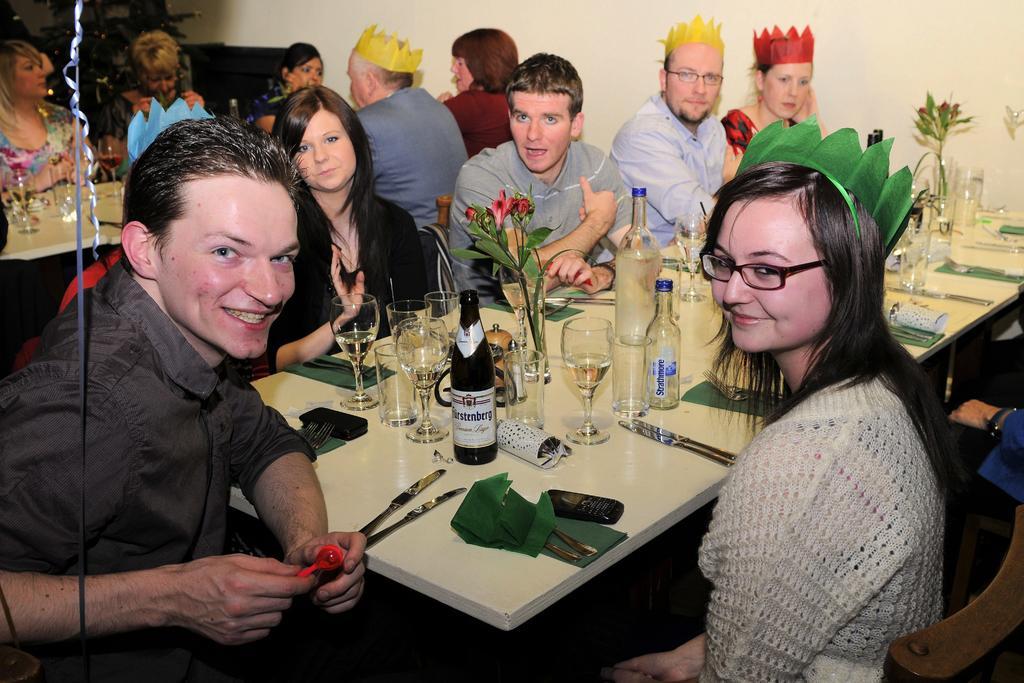In one or two sentences, can you explain what this image depicts? In this image people are sitting on chairs. In-front of them there are two tables, above the tables there are glasses, bottles, vases, flowers, knives, forks, mobile and things. Among them few people wore crowns. Left side of the image we can see plant and ribbon. 